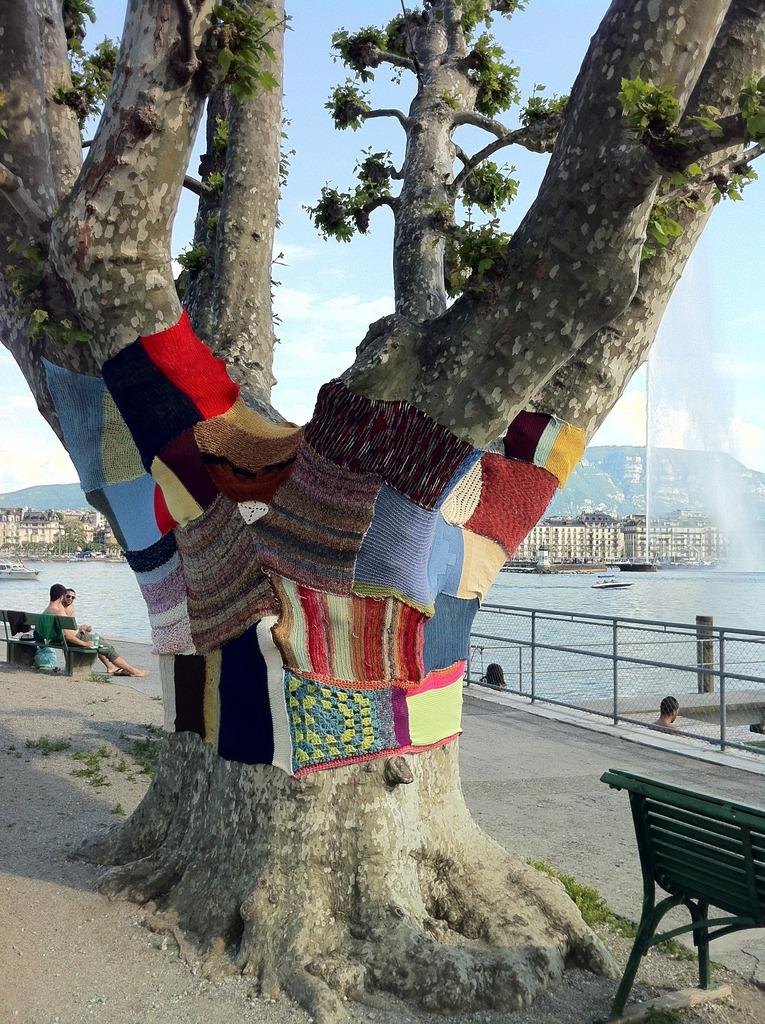What type of plant can be seen in the image? There is a tree present in the image. What type of seating is available in the image? There is a bench in the image. Who is sitting on the bench? A person is sitting on the bench. What can be seen besides the tree and bench? There is water and the sky visible in the image. What type of yam is being used as a pillow by the beast in the image? There is no yam or beast present in the image. What type of humor can be seen in the image? The image does not contain any humor; it is a straightforward depiction of a tree, bench, person, water, and sky. 